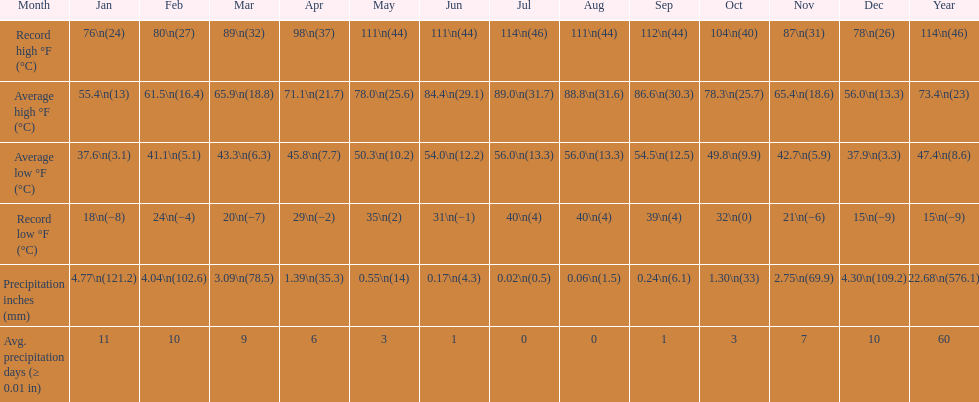0 degrees? July. 